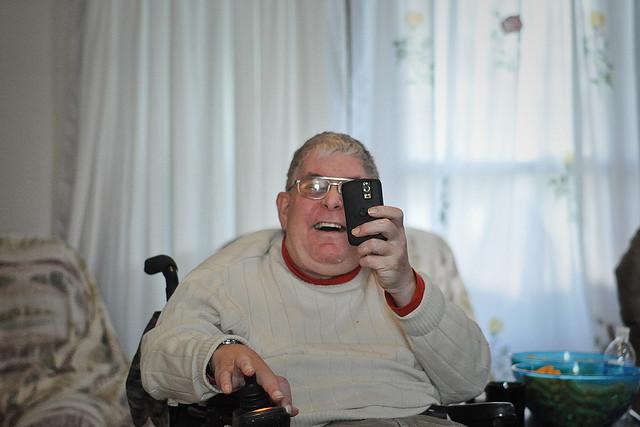What is he holding?
Keep it brief. Cell phone. What is the person holding?
Short answer required. Phone. What's the man doing?
Concise answer only. Taking picture. What is this person holding?
Concise answer only. Cell phone. Was this photo taken outside?
Keep it brief. No. What is the man sitting in?
Answer briefly. Wheelchair. Is the man cutting his hair?
Quick response, please. No. Is the light on the phone on?
Write a very short answer. No. Are there a couch in the background?
Be succinct. Yes. Is the man young?
Answer briefly. No. 